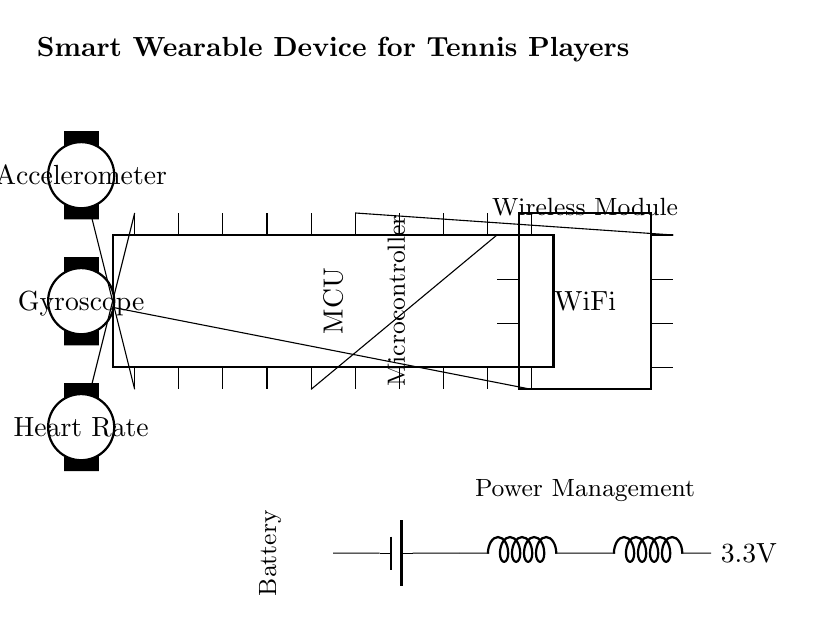What is the main microcontroller used in this device? The circuit diagram indicates a microcontroller labeled as "MCU," which is the main component responsible for processing data from various sensors.
Answer: MCU How many pins does the wireless module have? The diagram specifies that the wireless module, labeled "WiFi," has 8 pins, meaning it is designed for communication purposes in the circuit.
Answer: 8 What type of sensors are integrated into the device? The circuit includes three types of sensors: an accelerometer, a gyroscope, and a heart rate sensor, all of which provide different performance metrics relevant to tennis players.
Answer: Accelerometer, Gyroscope, Heart Rate What is the voltage supplied by the power management section? The power management section indicates a voltage output of 3.3V, which the microcontroller and sensors will operate on, ensuring proper functionality of the device.
Answer: 3.3V How are the sensors connected to the microcontroller? The accelerometer connects to pin 1, the gyroscope connects to pin 10, and the heart rate sensor connects to pin 20 of the microcontroller, establishing direct data transmission paths for performance tracking.
Answer: Direct connections What is the power source for the device? The circuit diagram shows a battery as the power source, which provides the necessary energy for the entire system, including the microcontroller and sensors.
Answer: Battery Why is wireless communication important for this device? Wireless communication, implemented through the WiFi module, allows the wearable device to transmit performance metrics in real-time to Coaching platforms or mobile applications, enhancing player training and feedback.
Answer: Real-time data transmission 